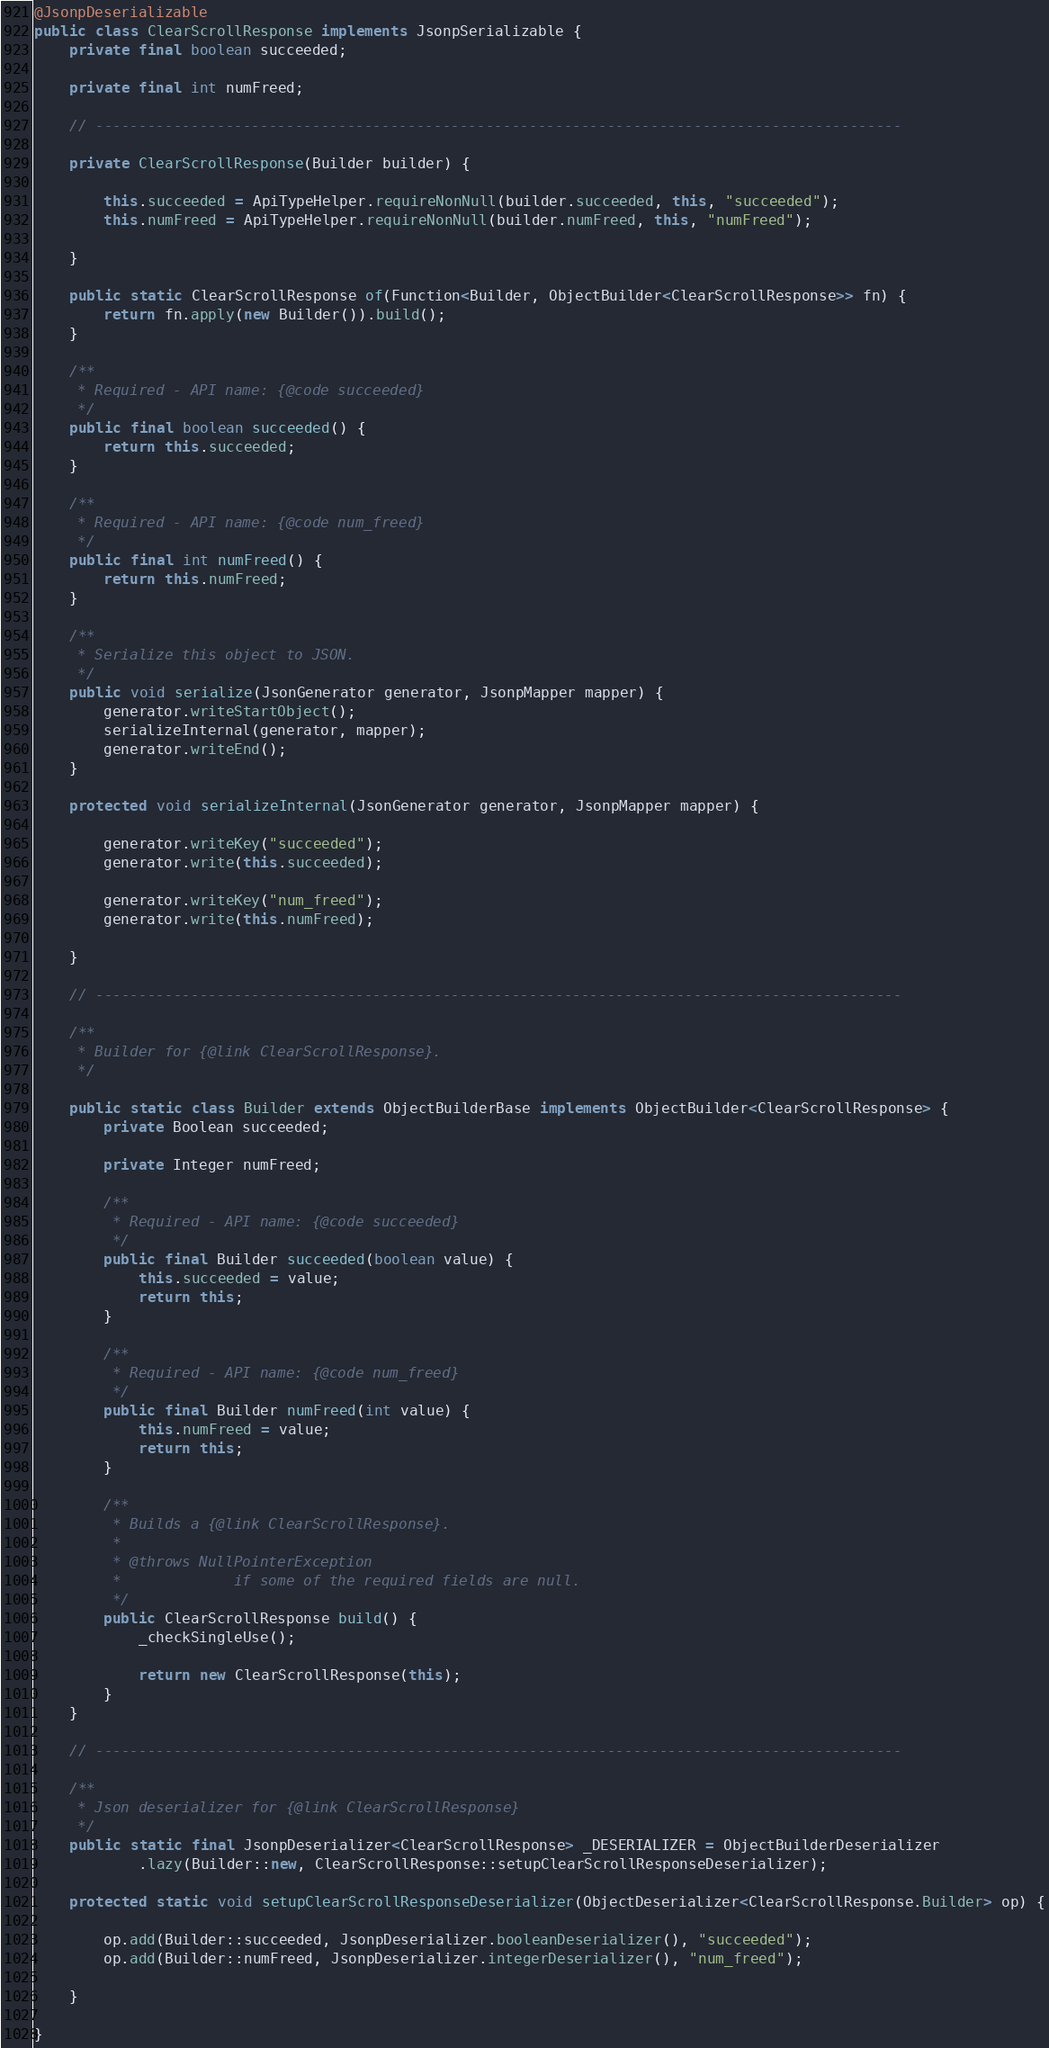Convert code to text. <code><loc_0><loc_0><loc_500><loc_500><_Java_>@JsonpDeserializable
public class ClearScrollResponse implements JsonpSerializable {
	private final boolean succeeded;

	private final int numFreed;

	// ---------------------------------------------------------------------------------------------

	private ClearScrollResponse(Builder builder) {

		this.succeeded = ApiTypeHelper.requireNonNull(builder.succeeded, this, "succeeded");
		this.numFreed = ApiTypeHelper.requireNonNull(builder.numFreed, this, "numFreed");

	}

	public static ClearScrollResponse of(Function<Builder, ObjectBuilder<ClearScrollResponse>> fn) {
		return fn.apply(new Builder()).build();
	}

	/**
	 * Required - API name: {@code succeeded}
	 */
	public final boolean succeeded() {
		return this.succeeded;
	}

	/**
	 * Required - API name: {@code num_freed}
	 */
	public final int numFreed() {
		return this.numFreed;
	}

	/**
	 * Serialize this object to JSON.
	 */
	public void serialize(JsonGenerator generator, JsonpMapper mapper) {
		generator.writeStartObject();
		serializeInternal(generator, mapper);
		generator.writeEnd();
	}

	protected void serializeInternal(JsonGenerator generator, JsonpMapper mapper) {

		generator.writeKey("succeeded");
		generator.write(this.succeeded);

		generator.writeKey("num_freed");
		generator.write(this.numFreed);

	}

	// ---------------------------------------------------------------------------------------------

	/**
	 * Builder for {@link ClearScrollResponse}.
	 */

	public static class Builder extends ObjectBuilderBase implements ObjectBuilder<ClearScrollResponse> {
		private Boolean succeeded;

		private Integer numFreed;

		/**
		 * Required - API name: {@code succeeded}
		 */
		public final Builder succeeded(boolean value) {
			this.succeeded = value;
			return this;
		}

		/**
		 * Required - API name: {@code num_freed}
		 */
		public final Builder numFreed(int value) {
			this.numFreed = value;
			return this;
		}

		/**
		 * Builds a {@link ClearScrollResponse}.
		 *
		 * @throws NullPointerException
		 *             if some of the required fields are null.
		 */
		public ClearScrollResponse build() {
			_checkSingleUse();

			return new ClearScrollResponse(this);
		}
	}

	// ---------------------------------------------------------------------------------------------

	/**
	 * Json deserializer for {@link ClearScrollResponse}
	 */
	public static final JsonpDeserializer<ClearScrollResponse> _DESERIALIZER = ObjectBuilderDeserializer
			.lazy(Builder::new, ClearScrollResponse::setupClearScrollResponseDeserializer);

	protected static void setupClearScrollResponseDeserializer(ObjectDeserializer<ClearScrollResponse.Builder> op) {

		op.add(Builder::succeeded, JsonpDeserializer.booleanDeserializer(), "succeeded");
		op.add(Builder::numFreed, JsonpDeserializer.integerDeserializer(), "num_freed");

	}

}
</code> 